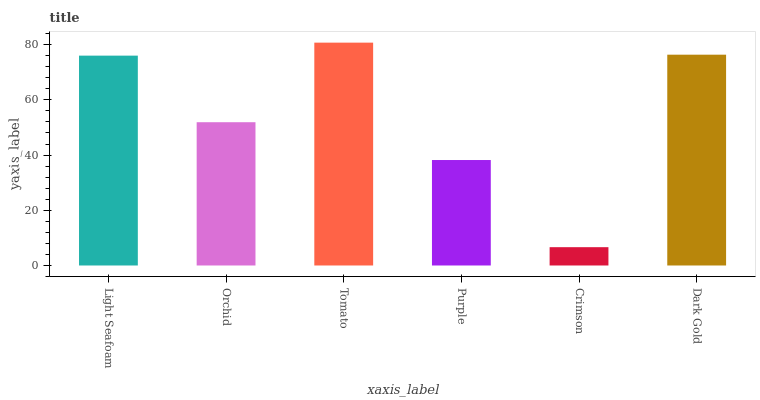Is Crimson the minimum?
Answer yes or no. Yes. Is Tomato the maximum?
Answer yes or no. Yes. Is Orchid the minimum?
Answer yes or no. No. Is Orchid the maximum?
Answer yes or no. No. Is Light Seafoam greater than Orchid?
Answer yes or no. Yes. Is Orchid less than Light Seafoam?
Answer yes or no. Yes. Is Orchid greater than Light Seafoam?
Answer yes or no. No. Is Light Seafoam less than Orchid?
Answer yes or no. No. Is Light Seafoam the high median?
Answer yes or no. Yes. Is Orchid the low median?
Answer yes or no. Yes. Is Tomato the high median?
Answer yes or no. No. Is Crimson the low median?
Answer yes or no. No. 